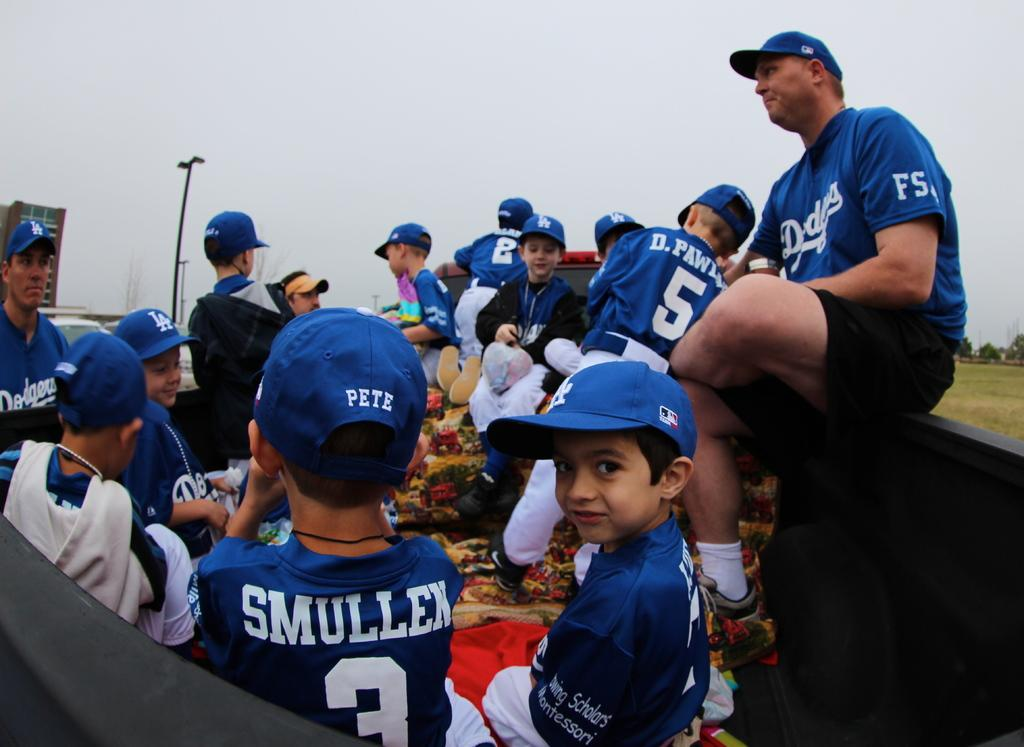<image>
Render a clear and concise summary of the photo. A little league Dodgers baseball team is gathered around for snacks. 